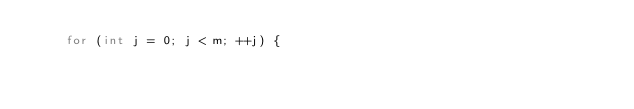<code> <loc_0><loc_0><loc_500><loc_500><_C++_>    for (int j = 0; j < m; ++j) {</code> 